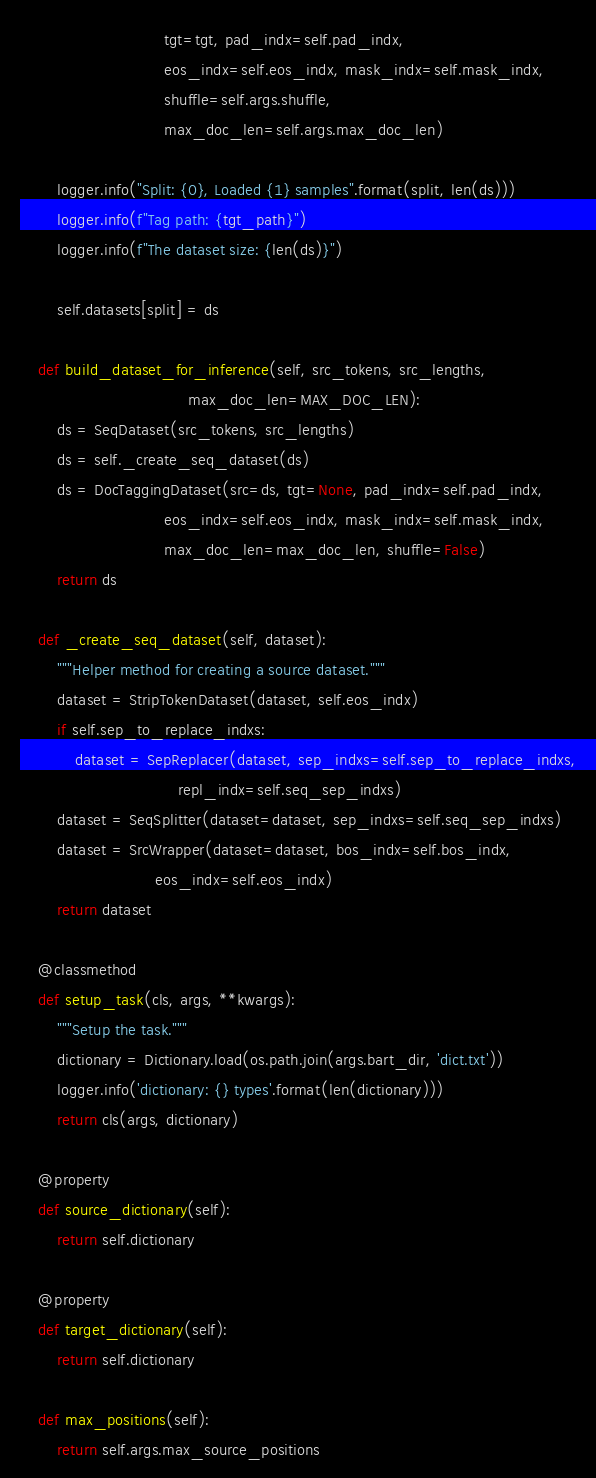<code> <loc_0><loc_0><loc_500><loc_500><_Python_>                               tgt=tgt, pad_indx=self.pad_indx,
                               eos_indx=self.eos_indx, mask_indx=self.mask_indx,
                               shuffle=self.args.shuffle,
                               max_doc_len=self.args.max_doc_len)

        logger.info("Split: {0}, Loaded {1} samples".format(split, len(ds)))
        logger.info(f"Tag path: {tgt_path}")
        logger.info(f"The dataset size: {len(ds)}")

        self.datasets[split] = ds

    def build_dataset_for_inference(self, src_tokens, src_lengths,
                                    max_doc_len=MAX_DOC_LEN):
        ds = SeqDataset(src_tokens, src_lengths)
        ds = self._create_seq_dataset(ds)
        ds = DocTaggingDataset(src=ds, tgt=None, pad_indx=self.pad_indx,
                               eos_indx=self.eos_indx, mask_indx=self.mask_indx,
                               max_doc_len=max_doc_len, shuffle=False)
        return ds

    def _create_seq_dataset(self, dataset):
        """Helper method for creating a source dataset."""
        dataset = StripTokenDataset(dataset, self.eos_indx)
        if self.sep_to_replace_indxs:
            dataset = SepReplacer(dataset, sep_indxs=self.sep_to_replace_indxs,
                                  repl_indx=self.seq_sep_indxs)
        dataset = SeqSplitter(dataset=dataset, sep_indxs=self.seq_sep_indxs)
        dataset = SrcWrapper(dataset=dataset, bos_indx=self.bos_indx,
                             eos_indx=self.eos_indx)
        return dataset

    @classmethod
    def setup_task(cls, args, **kwargs):
        """Setup the task."""
        dictionary = Dictionary.load(os.path.join(args.bart_dir, 'dict.txt'))
        logger.info('dictionary: {} types'.format(len(dictionary)))
        return cls(args, dictionary)

    @property
    def source_dictionary(self):
        return self.dictionary

    @property
    def target_dictionary(self):
        return self.dictionary

    def max_positions(self):
        return self.args.max_source_positions
</code> 